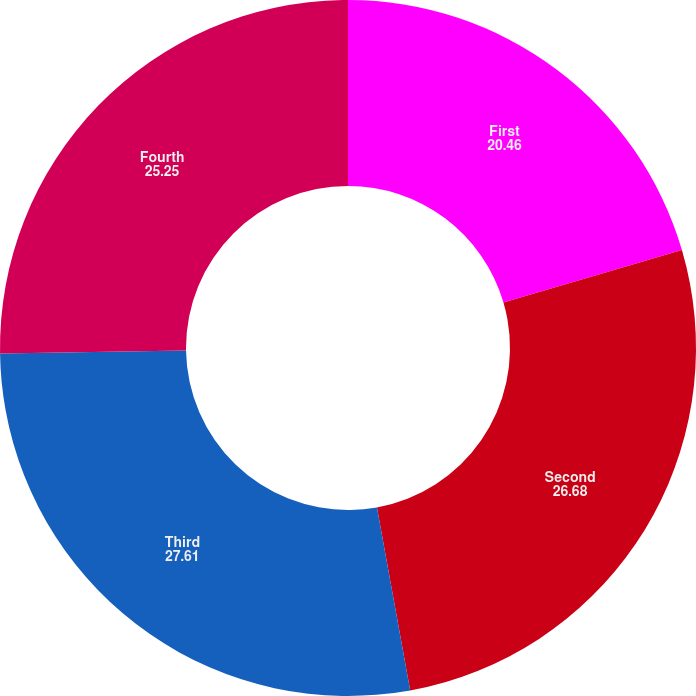<chart> <loc_0><loc_0><loc_500><loc_500><pie_chart><fcel>First<fcel>Second<fcel>Third<fcel>Fourth<nl><fcel>20.46%<fcel>26.68%<fcel>27.61%<fcel>25.25%<nl></chart> 